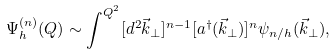Convert formula to latex. <formula><loc_0><loc_0><loc_500><loc_500>\Psi ^ { ( n ) } _ { h } ( Q ) \sim \int ^ { Q ^ { 2 } } [ d ^ { 2 } \vec { k } _ { \perp } ] ^ { n - 1 } [ a ^ { \dagger } ( \vec { k } _ { \perp } ) ] ^ { n } \psi _ { n / h } ( \vec { k } _ { \perp } ) ,</formula> 